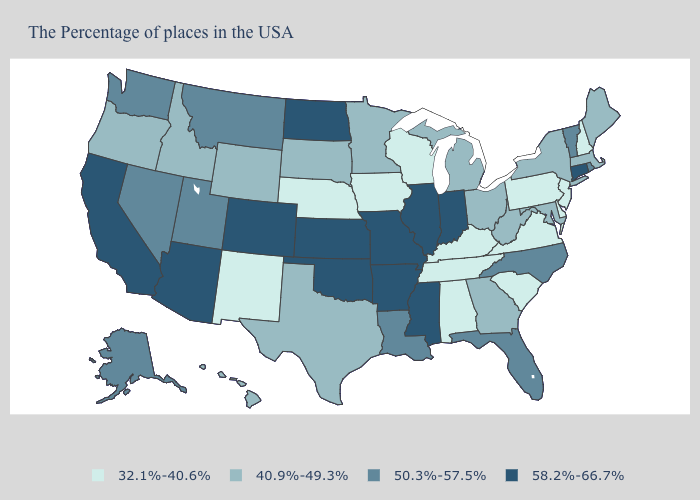Does Maryland have the highest value in the South?
Be succinct. No. What is the value of Virginia?
Write a very short answer. 32.1%-40.6%. What is the value of Mississippi?
Quick response, please. 58.2%-66.7%. What is the highest value in the USA?
Quick response, please. 58.2%-66.7%. Which states have the highest value in the USA?
Keep it brief. Connecticut, Indiana, Illinois, Mississippi, Missouri, Arkansas, Kansas, Oklahoma, North Dakota, Colorado, Arizona, California. How many symbols are there in the legend?
Concise answer only. 4. Does Tennessee have the same value as Pennsylvania?
Quick response, please. Yes. Does Connecticut have the lowest value in the USA?
Short answer required. No. Does Alaska have a higher value than Vermont?
Be succinct. No. What is the value of Michigan?
Give a very brief answer. 40.9%-49.3%. Does South Carolina have the same value as New Mexico?
Keep it brief. Yes. What is the value of South Carolina?
Write a very short answer. 32.1%-40.6%. Does Arizona have the lowest value in the West?
Short answer required. No. What is the highest value in states that border Maine?
Be succinct. 32.1%-40.6%. What is the highest value in states that border California?
Concise answer only. 58.2%-66.7%. 